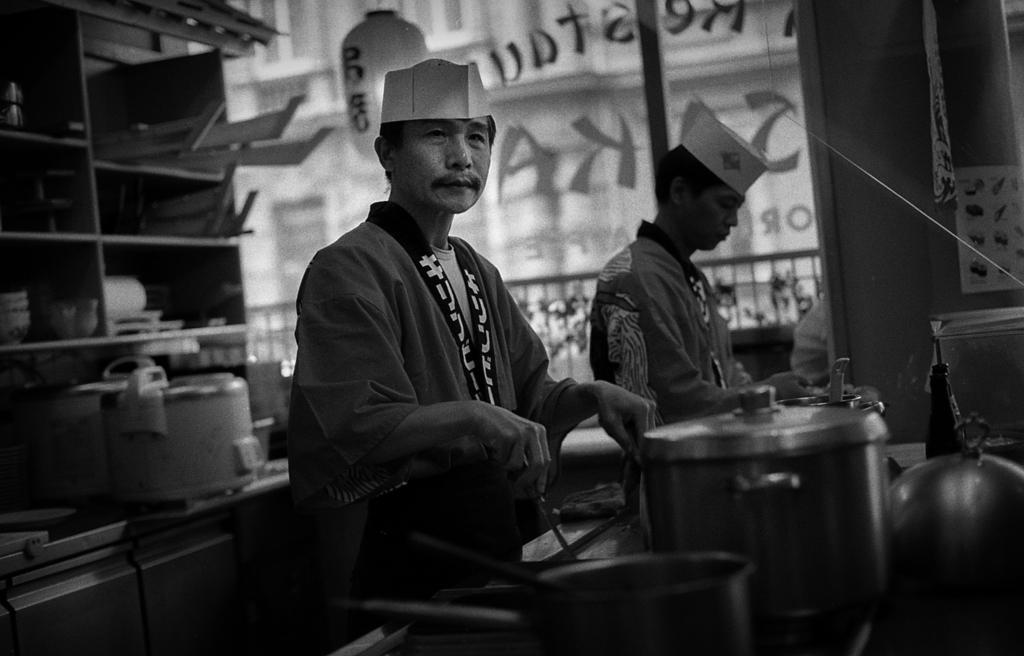Please provide a concise description of this image. In this picture I can see 2 men in front and I see that the man on the left is holding a thing in his hands and I see few utensils in front of them. In the background I see the racks on which there are few things and in the center of this picture I see the glass on which there is something written. I see that this is a black and white picture. 